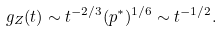<formula> <loc_0><loc_0><loc_500><loc_500>g _ { Z } ( t ) \sim t ^ { - 2 / 3 } ( p ^ { * } ) ^ { 1 / 6 } \sim t ^ { - 1 / 2 } .</formula> 